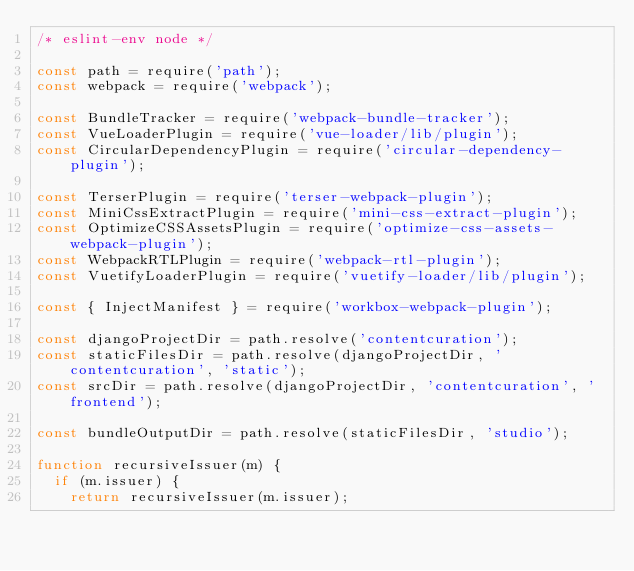Convert code to text. <code><loc_0><loc_0><loc_500><loc_500><_JavaScript_>/* eslint-env node */

const path = require('path');
const webpack = require('webpack');

const BundleTracker = require('webpack-bundle-tracker');
const VueLoaderPlugin = require('vue-loader/lib/plugin');
const CircularDependencyPlugin = require('circular-dependency-plugin');

const TerserPlugin = require('terser-webpack-plugin');
const MiniCssExtractPlugin = require('mini-css-extract-plugin');
const OptimizeCSSAssetsPlugin = require('optimize-css-assets-webpack-plugin');
const WebpackRTLPlugin = require('webpack-rtl-plugin');
const VuetifyLoaderPlugin = require('vuetify-loader/lib/plugin');

const { InjectManifest } = require('workbox-webpack-plugin');

const djangoProjectDir = path.resolve('contentcuration');
const staticFilesDir = path.resolve(djangoProjectDir, 'contentcuration', 'static');
const srcDir = path.resolve(djangoProjectDir, 'contentcuration', 'frontend');

const bundleOutputDir = path.resolve(staticFilesDir, 'studio');

function recursiveIssuer(m) {
  if (m.issuer) {
    return recursiveIssuer(m.issuer);</code> 